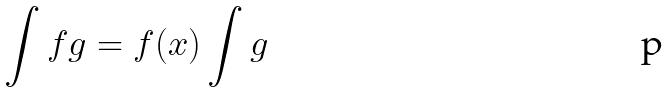Convert formula to latex. <formula><loc_0><loc_0><loc_500><loc_500>\int f g = f ( x ) \int g</formula> 